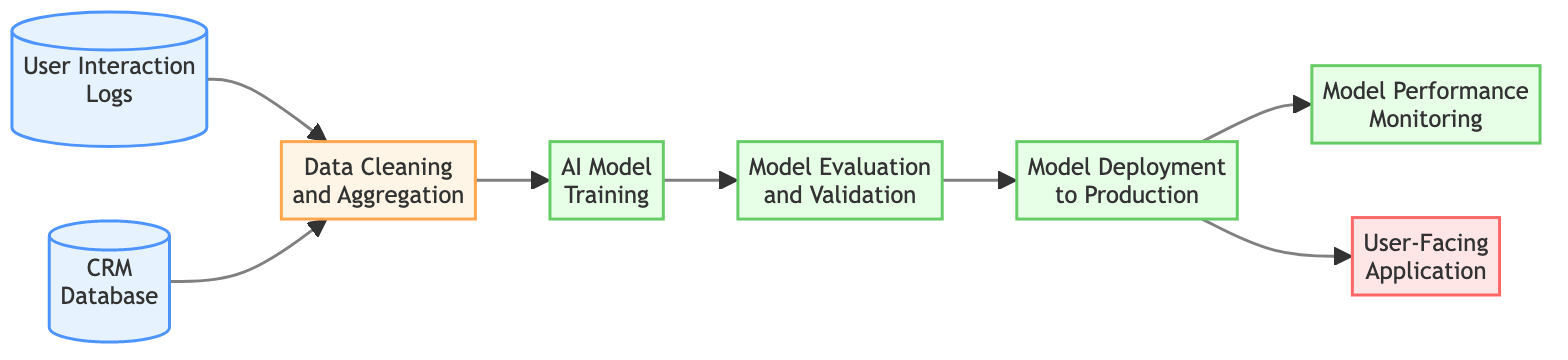What are the two data sources in the diagram? The diagram explicitly lists two data sources: "User Interaction Logs" and "CRM Database." These sources provide input data for the processing steps that follow.
Answer: User Interaction Logs, CRM Database What is the output of the Data Cleaning and Aggregation process? According to the flow in the diagram, the output of the "Data Cleaning and Aggregation" process is "AI Model Training," which is used for training the machine learning model.
Answer: AI Model Training How many outputs does the Model Deployment to Production process have? The diagram indicates that the "Model Deployment to Production" process has two outputs: "Model Performance Monitoring" and "User-Facing Application." This means it directs its results to both monitoring and application interfaces.
Answer: 2 Which nodes provide inputs to the AI Model Training process? The diagram shows that the "Data Cleaning and Aggregation" process feeds into the AI Model Training. This means that only the outputs from the preprocessing step serve as the input for the training step.
Answer: Data Cleaning and Aggregation What is the final output of the AI model deployment process? The last step in the diagram is "Model Deployment to Production," which has two outputs going to the next stages. Therefore, in a broader sense, the final outputs from the deployment process are the performance monitoring and the application interface.
Answer: Model Performance Monitoring, User-Facing Application How does the Model Evaluation and Validation process relate to Model Training? The flowchart shows that the "Model Evaluation and Validation" directly follows "AI Model Training," indicating that it takes the trained model as input for evaluation, establishing a sequential relationship to ensure the trained model is assessed for validity.
Answer: Sequential relationship What type of monitoring occurs after model deployment? The "Model Performance Monitoring" process occurs after the deployment of the model, as it continuously monitors the performance of the AI model in production. This connection emphasizes the importance of tracking the model’s effectiveness post-deployment.
Answer: Model Performance Monitoring Which process involves cleaning and aggregating data? The "Data Cleaning and Aggregation" process is specifically responsible for cleaning and aggregating data from multiple sources, as indicated in the diagram, outlining its role in preparing data for training.
Answer: Data Cleaning and Aggregation What are the roles of the final nodes in the diagram? The final nodes are "Model Performance Monitoring" and "User-Facing Application," which serve two distinct roles: the former monitors the model's ongoing performance while the latter provides a platform for users to interact with the AI application.
Answer: Monitoring, Application Interface 